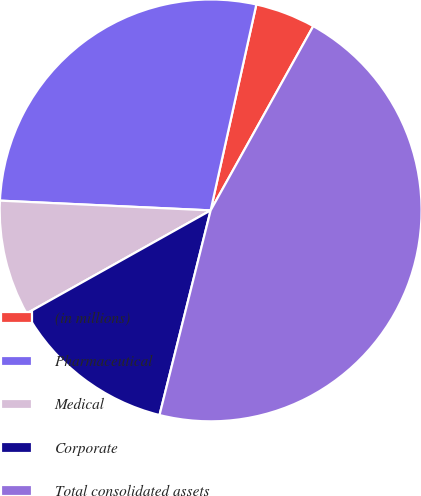Convert chart to OTSL. <chart><loc_0><loc_0><loc_500><loc_500><pie_chart><fcel>(in millions)<fcel>Pharmaceutical<fcel>Medical<fcel>Corporate<fcel>Total consolidated assets<nl><fcel>4.61%<fcel>27.74%<fcel>8.86%<fcel>12.98%<fcel>45.81%<nl></chart> 